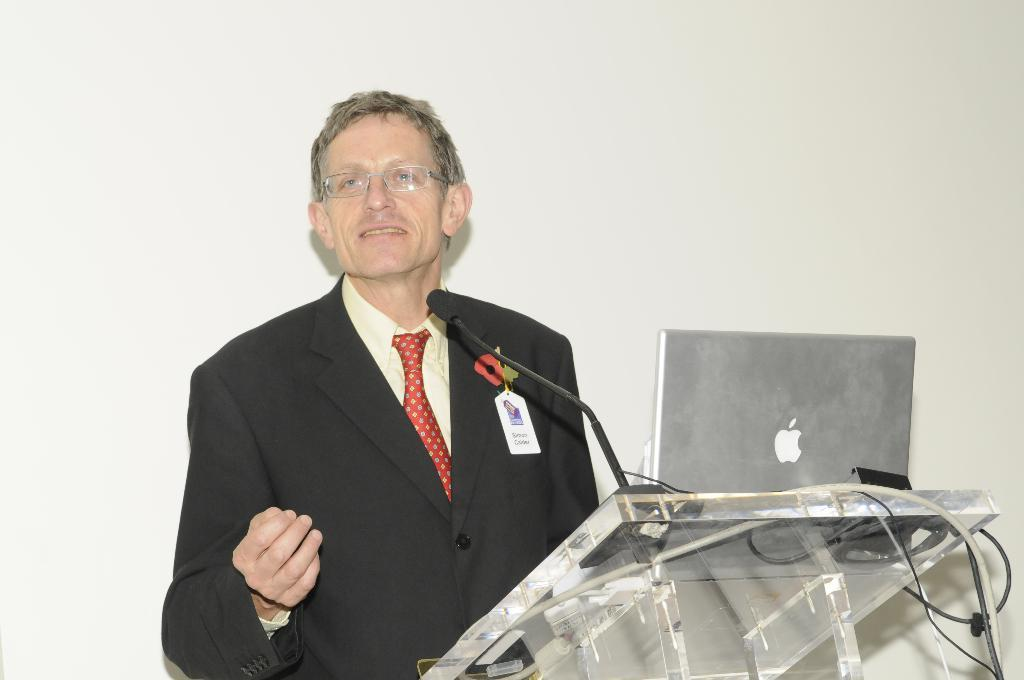What is the person in the image wearing? There is a person wearing a suit in the image. What is the person doing in the image? The person is standing. What electronic device is visible in the image? There is a laptop in the image. What is the purpose of the mic in the image? The mic is placed on a stand in front of the person, suggesting it might be used for recording or amplifying sound. How many basketballs are visible in the image? There are no basketballs present in the image. What type of birds can be seen in the image? There are no birds, including ducks, present in the image. 